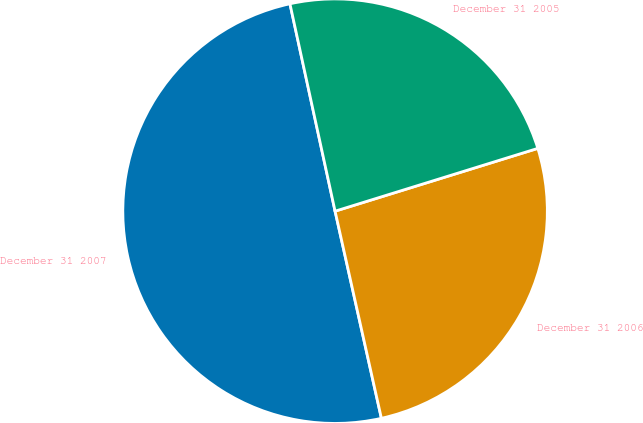<chart> <loc_0><loc_0><loc_500><loc_500><pie_chart><fcel>December 31 2007<fcel>December 31 2006<fcel>December 31 2005<nl><fcel>50.09%<fcel>26.28%<fcel>23.63%<nl></chart> 